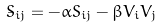<formula> <loc_0><loc_0><loc_500><loc_500>\dot { S } _ { i j } = - \alpha S _ { i j } - \beta V _ { i } V _ { j }</formula> 